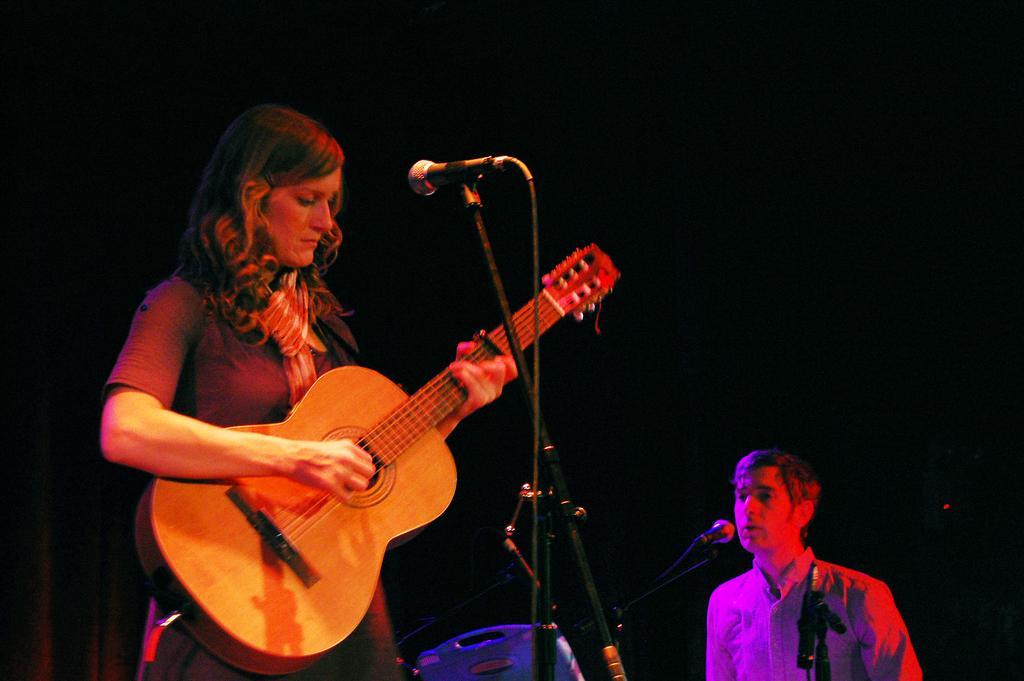In one or two sentences, can you explain what this image depicts? There is a woman holding and playing a guitar. This is a mike with the mike stand. There is a man standing and singing a song using a mike. 